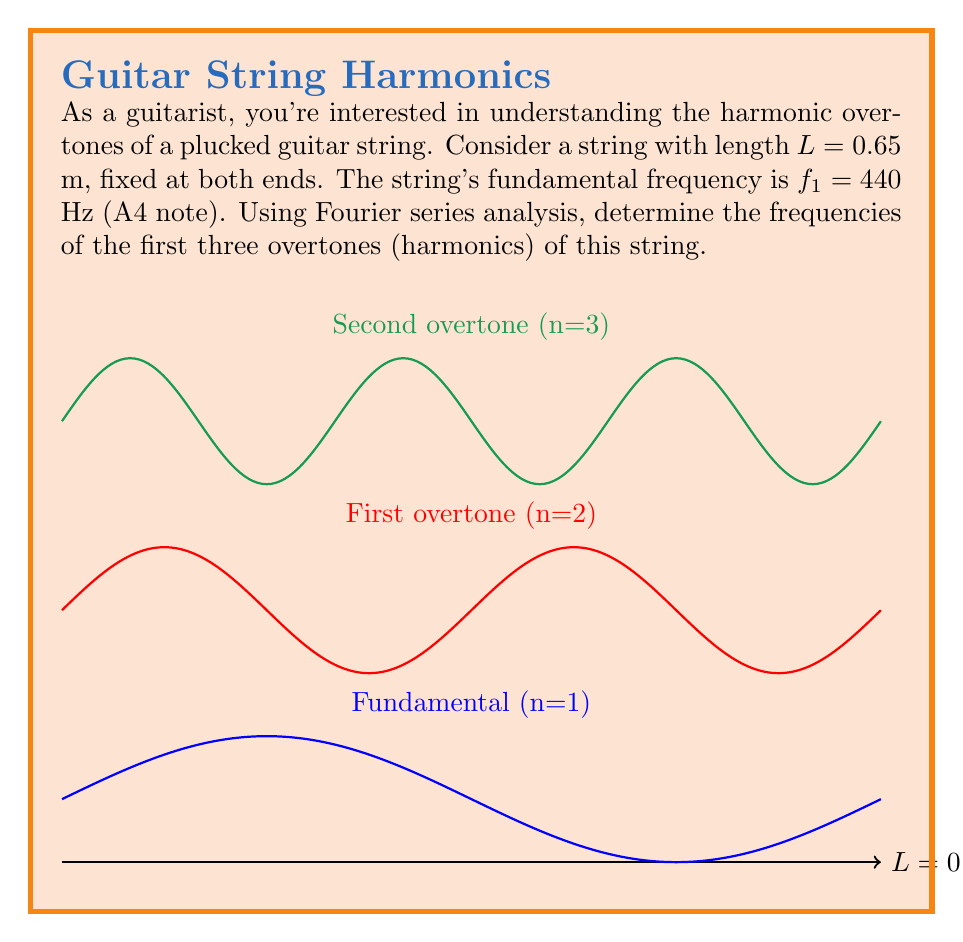Teach me how to tackle this problem. Let's approach this step-by-step:

1) In a vibrating string fixed at both ends, the wavelength $\lambda$ of the fundamental frequency (n=1) is related to the string length L by:

   $$L = \frac{\lambda}{2}$$

2) The speed of the wave $v$ in the string is given by:

   $$v = f\lambda$$

3) For the fundamental frequency $f_1 = 440$ Hz, we can calculate the wave speed:

   $$v = f_1 \cdot 2L = 440 \cdot 2 \cdot 0.65 = 572 \text{ m/s}$$

4) The frequencies of the overtones are integer multiples of the fundamental frequency. In general, for the nth harmonic:

   $$f_n = n \cdot f_1$$

5) Therefore, the first three overtones (n = 2, 3, 4) have frequencies:

   Second harmonic (first overtone): $f_2 = 2 \cdot 440 = 880 \text{ Hz}$
   Third harmonic (second overtone): $f_3 = 3 \cdot 440 = 1320 \text{ Hz}$
   Fourth harmonic (third overtone): $f_4 = 4 \cdot 440 = 1760 \text{ Hz}$

These overtones contribute to the rich timbre of a plucked guitar string.
Answer: 880 Hz, 1320 Hz, 1760 Hz 